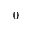Convert formula to latex. <formula><loc_0><loc_0><loc_500><loc_500>0</formula> 